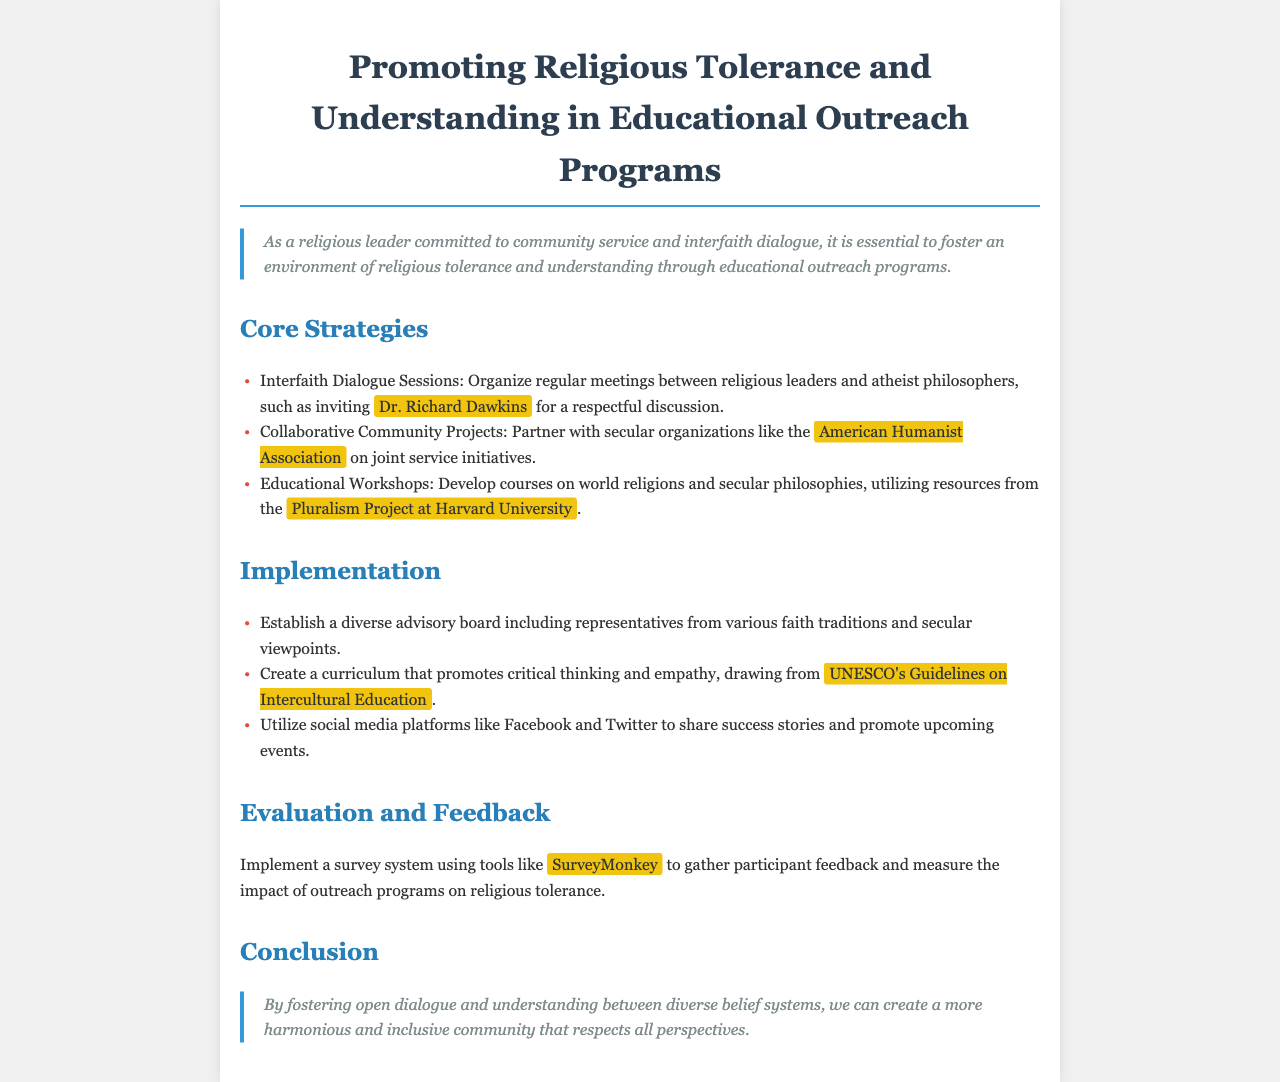What is the title of the document? The title of the document is explicitly stated in the header section of the document.
Answer: Promoting Religious Tolerance and Understanding in Educational Outreach Programs Who is mentioned as a participant in interfaith dialogue sessions? The document specifies Dr. Richard Dawkins as an invited participant for respectful discussions in the interfaith dialogue sessions.
Answer: Dr. Richard Dawkins Which organization is suggested for partnership on community projects? The document mentions the American Humanist Association as a partner for joint service initiatives.
Answer: American Humanist Association What educational resource is referenced for developing courses? The Pluralism Project at Harvard University is noted as a resource for developing educational courses on world religions and secular philosophies.
Answer: Pluralism Project at Harvard University What tool is recommended for implementing participant feedback surveys? The document suggests using SurveyMonkey as a tool to gather participant feedback.
Answer: SurveyMonkey What is a core strategy for promoting religious tolerance? One of the core strategies highlighted in the document is organizing interfaith dialogue sessions.
Answer: Interfaith Dialogue Sessions What type of curriculum is suggested in the implementation section? The curriculum suggested should promote critical thinking and empathy, based on UNESCO's Guidelines on Intercultural Education.
Answer: Critical thinking and empathy How many key sections are in the document? The document outlines core strategies, implementation, evaluation and feedback, and conclusion, which indicates there are four key sections.
Answer: Four Which social media platforms are recommended for sharing success stories? The document specifies utilizing Facebook and Twitter for sharing success stories and promoting events.
Answer: Facebook and Twitter 